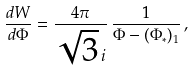<formula> <loc_0><loc_0><loc_500><loc_500>\frac { d W } { d \Phi } = \frac { 4 \pi } { \sqrt { 3 } \, i } \, \frac { 1 } { \Phi - ( \Phi _ { * } ) _ { 1 } } \, ,</formula> 